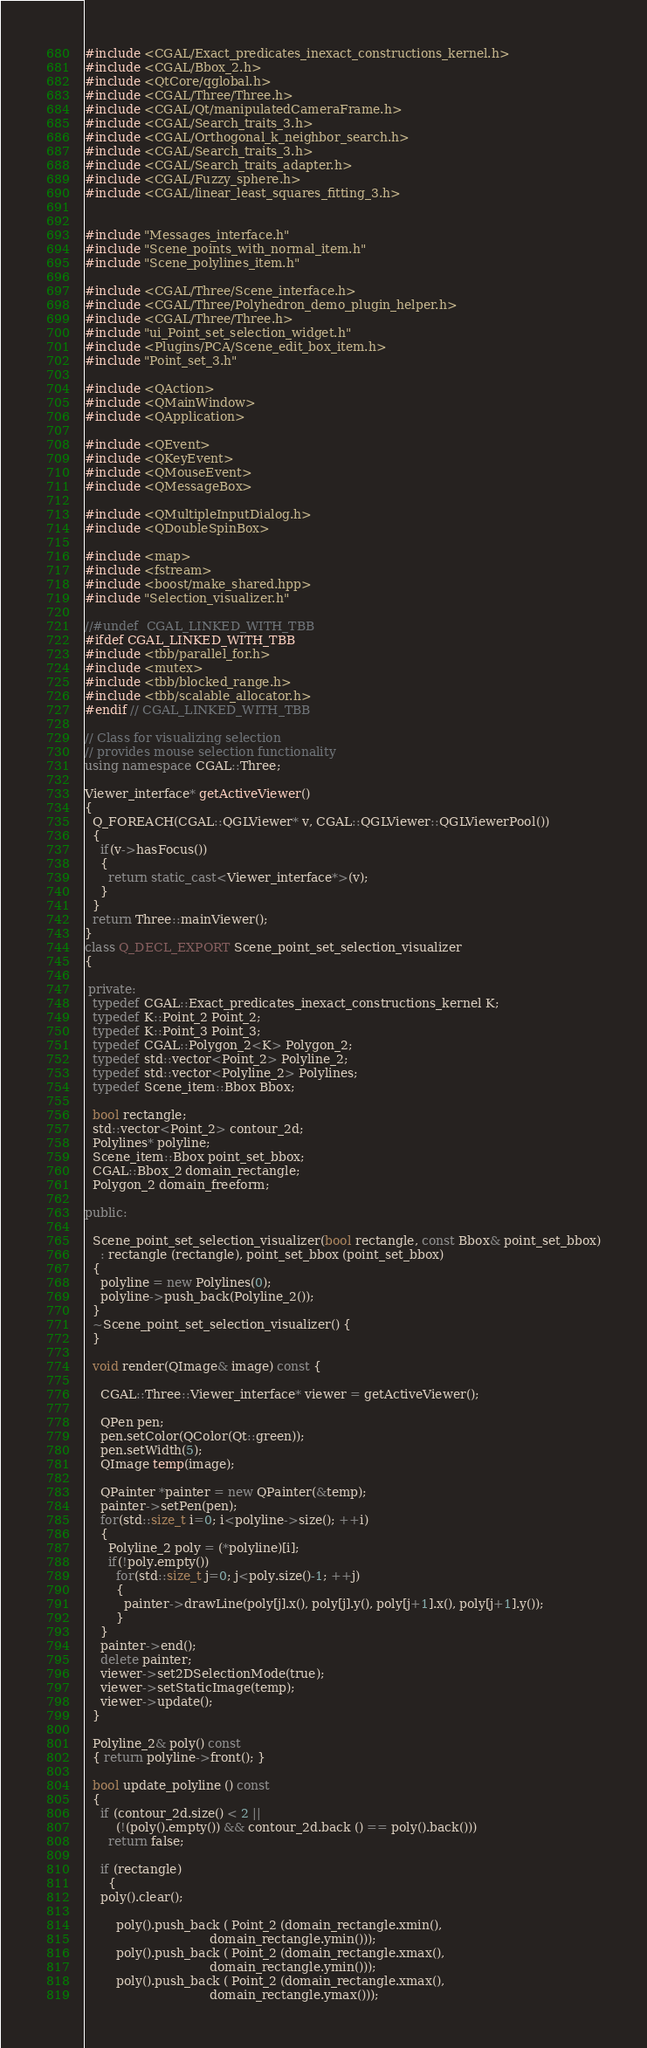<code> <loc_0><loc_0><loc_500><loc_500><_C++_>#include <CGAL/Exact_predicates_inexact_constructions_kernel.h>
#include <CGAL/Bbox_2.h>
#include <QtCore/qglobal.h>
#include <CGAL/Three/Three.h>
#include <CGAL/Qt/manipulatedCameraFrame.h>
#include <CGAL/Search_traits_3.h>
#include <CGAL/Orthogonal_k_neighbor_search.h>
#include <CGAL/Search_traits_3.h>
#include <CGAL/Search_traits_adapter.h>
#include <CGAL/Fuzzy_sphere.h>
#include <CGAL/linear_least_squares_fitting_3.h>


#include "Messages_interface.h"
#include "Scene_points_with_normal_item.h"
#include "Scene_polylines_item.h"

#include <CGAL/Three/Scene_interface.h>
#include <CGAL/Three/Polyhedron_demo_plugin_helper.h>
#include <CGAL/Three/Three.h>
#include "ui_Point_set_selection_widget.h"
#include <Plugins/PCA/Scene_edit_box_item.h>
#include "Point_set_3.h"

#include <QAction>
#include <QMainWindow>
#include <QApplication>

#include <QEvent>
#include <QKeyEvent>
#include <QMouseEvent>
#include <QMessageBox>

#include <QMultipleInputDialog.h>
#include <QDoubleSpinBox>

#include <map>
#include <fstream>
#include <boost/make_shared.hpp>
#include "Selection_visualizer.h"

//#undef  CGAL_LINKED_WITH_TBB
#ifdef CGAL_LINKED_WITH_TBB
#include <tbb/parallel_for.h>
#include <mutex>
#include <tbb/blocked_range.h>
#include <tbb/scalable_allocator.h>  
#endif // CGAL_LINKED_WITH_TBB

// Class for visualizing selection 
// provides mouse selection functionality
using namespace CGAL::Three;

Viewer_interface* getActiveViewer()
{
  Q_FOREACH(CGAL::QGLViewer* v, CGAL::QGLViewer::QGLViewerPool())
  {
    if(v->hasFocus())
    {
      return static_cast<Viewer_interface*>(v);
    }
  }
  return Three::mainViewer();
}
class Q_DECL_EXPORT Scene_point_set_selection_visualizer
{

 private:
  typedef CGAL::Exact_predicates_inexact_constructions_kernel K;
  typedef K::Point_2 Point_2;
  typedef K::Point_3 Point_3;
  typedef CGAL::Polygon_2<K> Polygon_2;
  typedef std::vector<Point_2> Polyline_2;
  typedef std::vector<Polyline_2> Polylines;
  typedef Scene_item::Bbox Bbox;
  
  bool rectangle;
  std::vector<Point_2> contour_2d;
  Polylines* polyline;
  Scene_item::Bbox point_set_bbox;
  CGAL::Bbox_2 domain_rectangle;
  Polygon_2 domain_freeform;
  
public:

  Scene_point_set_selection_visualizer(bool rectangle, const Bbox& point_set_bbox)
    : rectangle (rectangle), point_set_bbox (point_set_bbox)
  {
    polyline = new Polylines(0);
    polyline->push_back(Polyline_2());
  }
  ~Scene_point_set_selection_visualizer() {
  }

  void render(QImage& image) const {

    CGAL::Three::Viewer_interface* viewer = getActiveViewer();

    QPen pen;
    pen.setColor(QColor(Qt::green));
    pen.setWidth(5);
    QImage temp(image);

    QPainter *painter = new QPainter(&temp);
    painter->setPen(pen);
    for(std::size_t i=0; i<polyline->size(); ++i)
    {
      Polyline_2 poly = (*polyline)[i];
      if(!poly.empty())
        for(std::size_t j=0; j<poly.size()-1; ++j)
        {
          painter->drawLine(poly[j].x(), poly[j].y(), poly[j+1].x(), poly[j+1].y());
        }
    }
    painter->end();
    delete painter;
    viewer->set2DSelectionMode(true);
    viewer->setStaticImage(temp);
    viewer->update();
  }

  Polyline_2& poly() const
  { return polyline->front(); }
  
  bool update_polyline () const
  {
    if (contour_2d.size() < 2 ||
        (!(poly().empty()) && contour_2d.back () == poly().back()))
      return false;
    
    if (rectangle)
      {
	poly().clear();
	
        poly().push_back ( Point_2 (domain_rectangle.xmin(),
                                domain_rectangle.ymin()));
        poly().push_back ( Point_2 (domain_rectangle.xmax(),
                                domain_rectangle.ymin()));
        poly().push_back ( Point_2 (domain_rectangle.xmax(),
                                domain_rectangle.ymax()));</code> 